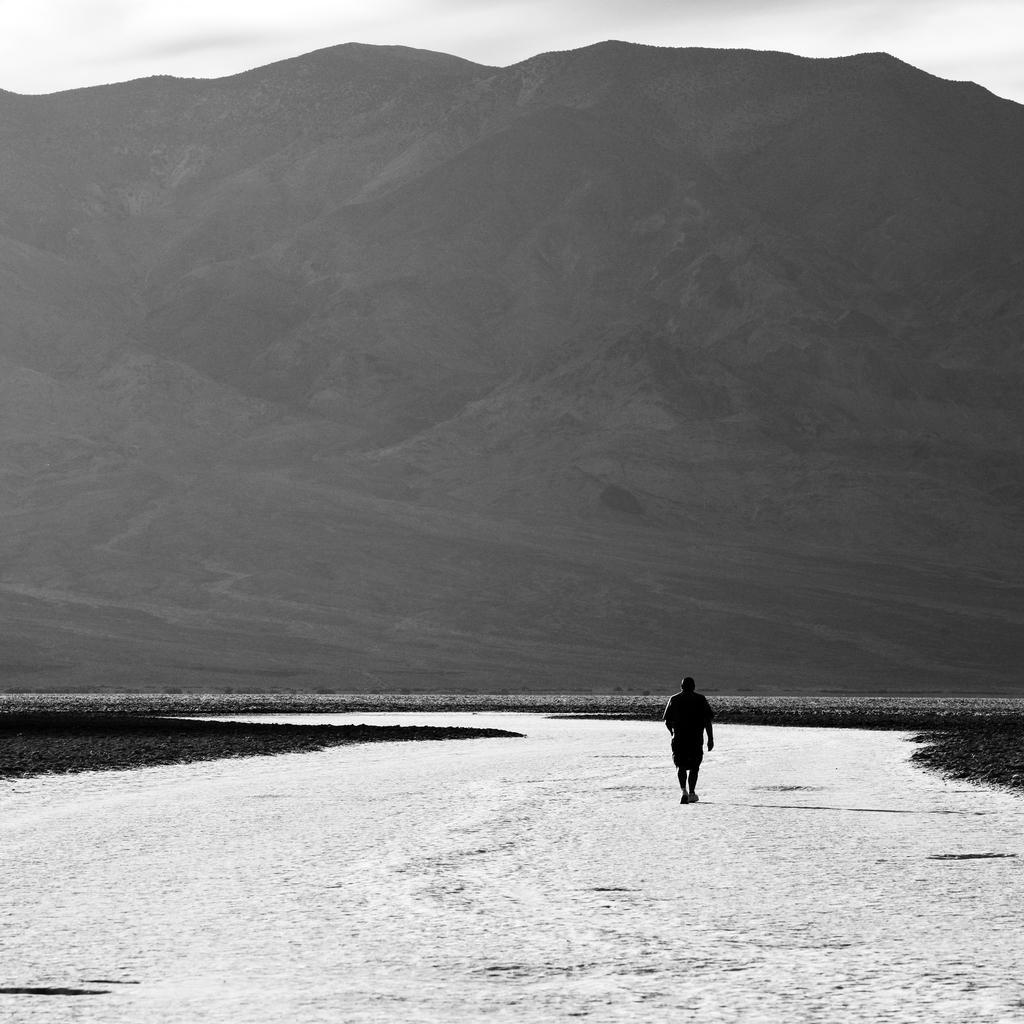Describe this image in one or two sentences. It is a black and white image. In this image, we can see a person on the walkway. Background we can see the hill and sky. 